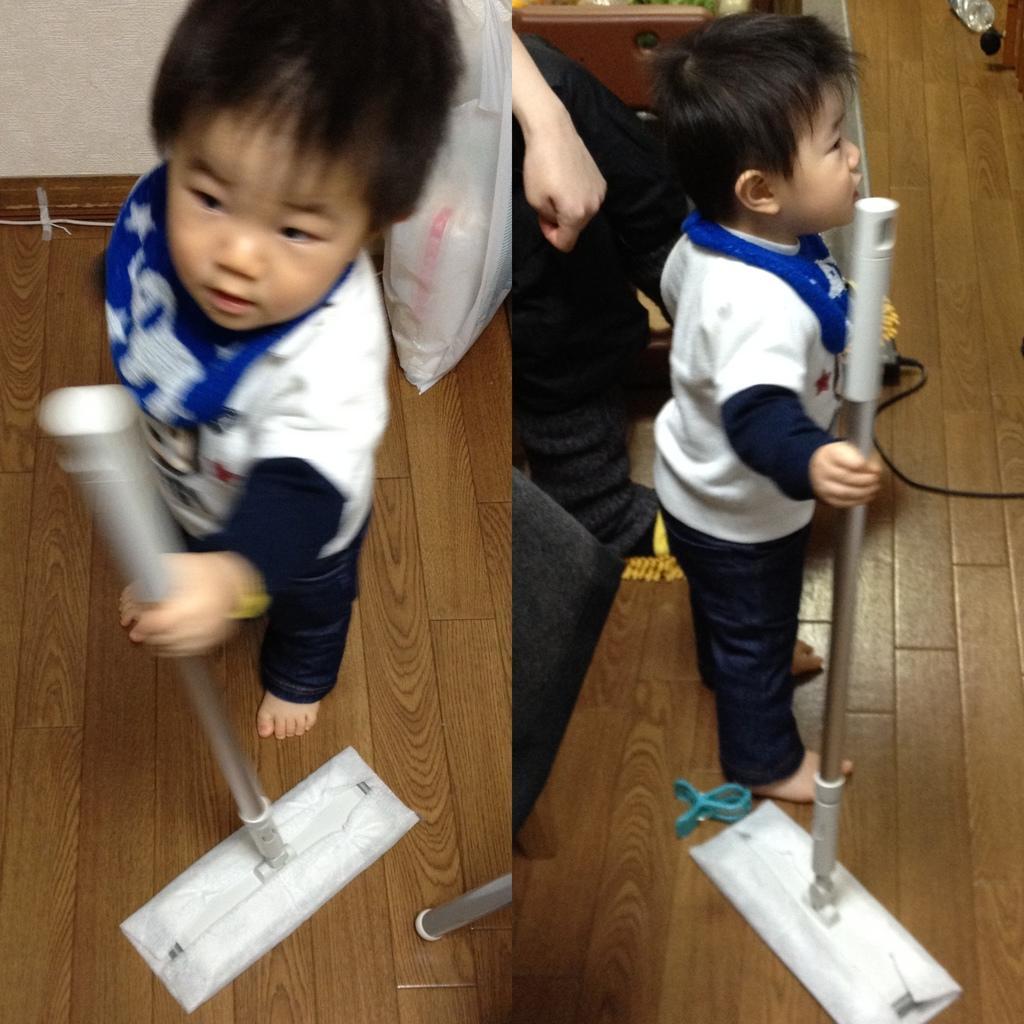How would you summarize this image in a sentence or two? This is a collage picture. I can see a kid standing and holding a stick, there is a person and there are some objects. 